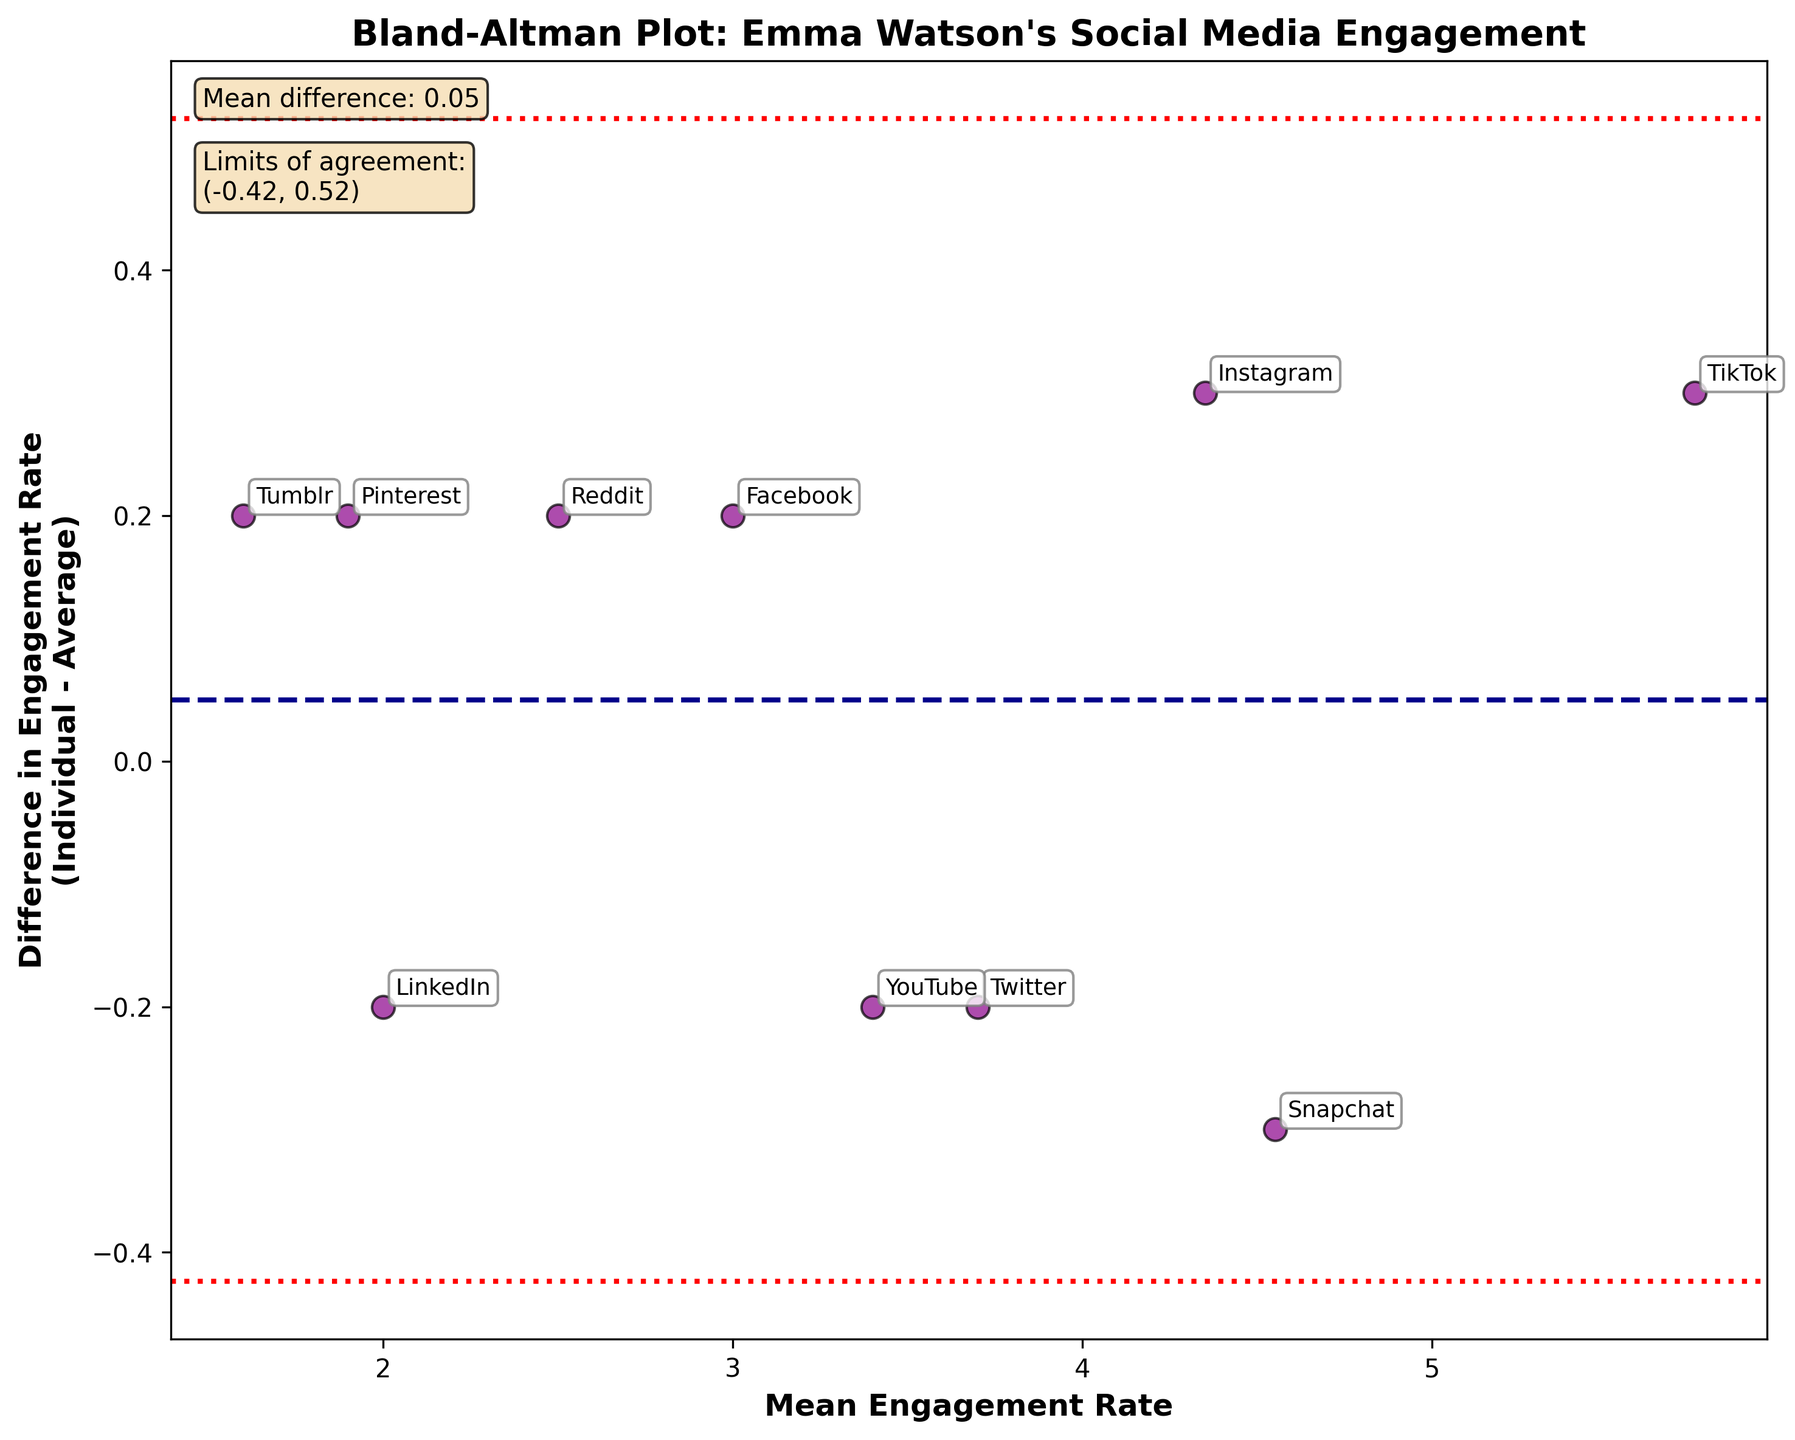What is the title of the plot? The title of the plot is typically displayed at the top of the plot. In the given figure, the title is clearly mentioned at the top center.
Answer: "Bland-Altman Plot: Emma Watson's Social Media Engagement" How many social media platforms are analyzed in the plot? Each point on the Bland-Altman plot represents a different social media platform. By counting these points, we determine the number of platforms.
Answer: 10 What is the color and size of the data points in the plot? The data points are described as being colored in dark magenta and sized at 80 points with a black edge color.
Answer: Dark magenta, 80 points What does the mean difference represent, and where is it shown in the plot? The mean difference represents the average of the differences between the individual and average engagement rates. It is shown as a horizontal dashed line on the plot, and its value is displayed in a text box on the top left.
Answer: Average of differences; shown as a horizontal dashed line and text box What are the limits of agreement in the plot? The limits of agreement are calculated as mean difference ± 1.96 standard deviations. These limits are shown as dotted red lines on the plot, and the exact values are displayed in a text box on the top left.
Answer: (-0.47, 0.47) Which platform has the highest mean engagement rate, and what is its value? By examining the furthest right point along the x-axis, we can identify the platform with the highest mean engagement rate. In this plot, it is TikTok.
Answer: TikTok, 5.75 What is the mean engagement rate for Instagram, and how does its individual engagement rate differ from this mean? Locate the point labeled 'Instagram' and find its x-coordinate for the mean engagement rate and its y-coordinate for the difference. The mean is 4.35, and the difference is 0.3.
Answer: Mean: 4.35, Difference: 0.3 Which platforms lie outside the limits of agreement, and what does this imply? Points outside the red dotted lines indicate platforms where the individual engagement rate deviates significantly from the average. Compare which points fall beyond these boundaries.
Answer: None, all points are within the limits What is the difference in engagement rate for Snapchat, and how does it compare to the mean difference? Find the point labeled 'Snapchat' and check its y-coordinate for the difference value. Compare this to the mean difference indicated by the horizontal dashed line.
Answer: -0.3; less than mean difference Calculate the mean engagement rate for YouTube and compare it to Reddit. Which is higher? Locate points labeled 'YouTube' and 'Reddit'. Compare their x-coordinates (mean engagement rates). YouTube's is 3.4, Reddit's is 2.5.
Answer: YouTube, 3.4 